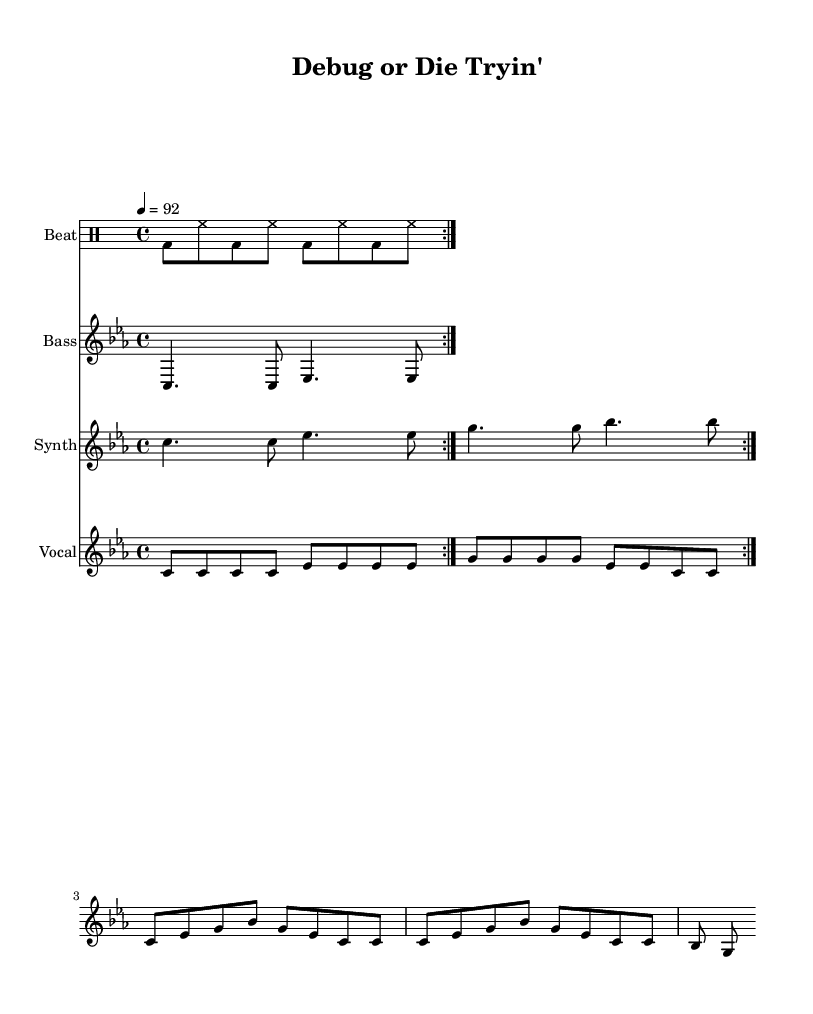What is the key signature of this music? The key signature is indicated at the beginning of the score where it shows "c \minor," meaning it is C minor which has three flats.
Answer: C minor What is the time signature of the piece? The time signature is stated in the score as "4/4," indicating that there are four beats in each measure and the quarter note gets one beat.
Answer: 4/4 What is the tempo marking for this piece? The tempo marking appears as "4 = 92," meaning the quarter note should be played at a speed of 92 beats per minute.
Answer: 92 How many repeats are indicated for the drum beat? The drum beat section indicates "\repeat volta 2," meaning it should be repeated twice.
Answer: 2 What is the highest note in the vocal line? The highest note in the vocal line is "g," which can be found in the vocal part and is the top note in several measures.
Answer: g How many vocal phrases are there in the lyrics? The lyrics contain three distinct phrases that can be identified by the line breaks, leading to a total of three vocal phrases in the lower staff.
Answer: 3 What is the theme of the lyrics presented in the vocal line? The lyrics talk about coding struggles and the frustrations related to debugging process, particularly in the context of programming.
Answer: Debugging struggles 